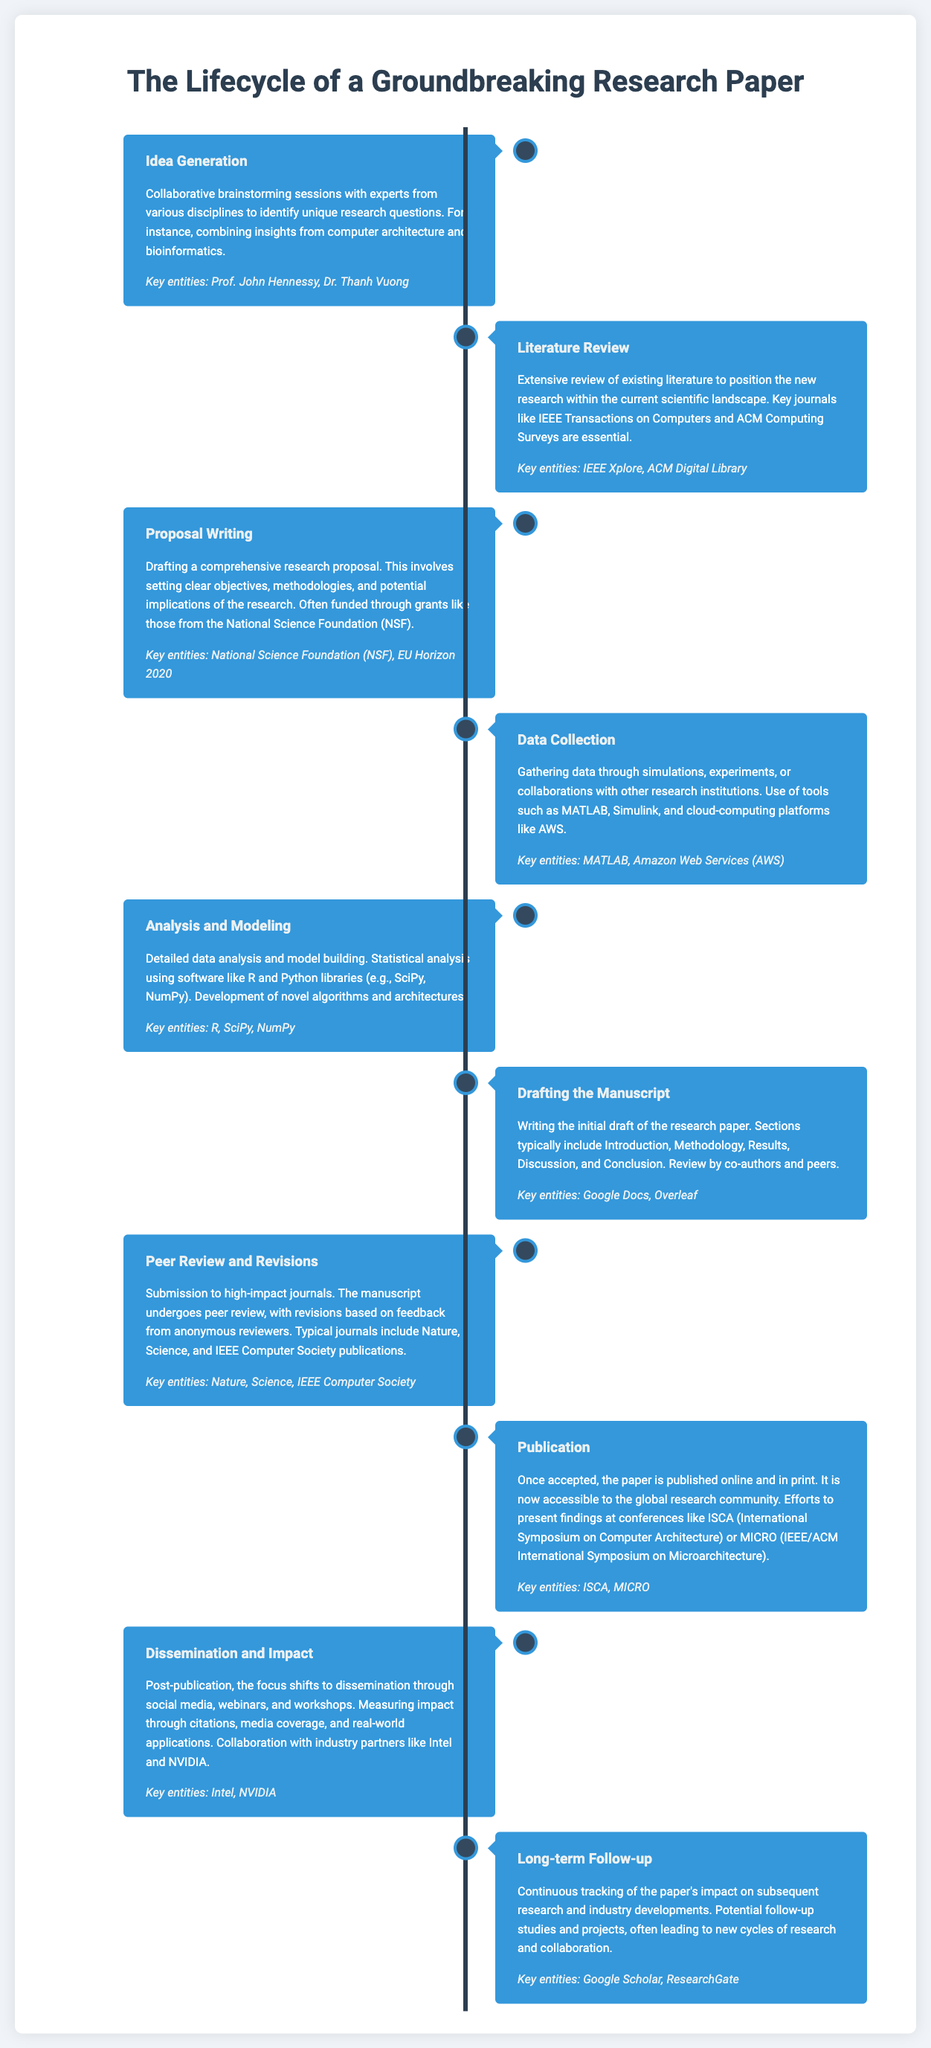What is the first stage in the research paper lifecycle? The first stage in the lifecycle is identified in the document as Idea Generation, which involves collaborative brainstorming sessions.
Answer: Idea Generation Who is listed as a key entity in the Idea Generation stage? The document mentions Prof. John Hennessy and Dr. Thanh Vuong as key entities in the Idea Generation stage.
Answer: Prof. John Hennessy, Dr. Thanh Vuong What is the purpose of the Literature Review stage? The Literature Review stage aims to position the new research within the current scientific landscape by reviewing existing literature.
Answer: Positioning research Which software tools are used in the Data Collection stage? The document specifies that tools like MATLAB and cloud-computing platforms like AWS are used in the Data Collection stage.
Answer: MATLAB, Amazon Web Services What type of journals are involved in the Peer Review and Revisions stage? The Peer Review and Revisions stage involves submitting to high-impact journals such as Nature and Science.
Answer: Nature, Science What is highlighted as a focus after Publication? The document states that after Publication, the focus shifts to Dissemination and Impact, emphasizing sharing findings with the research community.
Answer: Dissemination and Impact How does the document describe long-term follow-up activities? The Long-term Follow-up section describes continuous tracking of the paper's impact and potential follow-up studies.
Answer: Continuous tracking What critical collaboration is mentioned in the Dissemination and Impact stage? The document highlights collaboration with industry partners such as Intel and NVIDIA in the Dissemination and Impact stage.
Answer: Intel, NVIDIA 